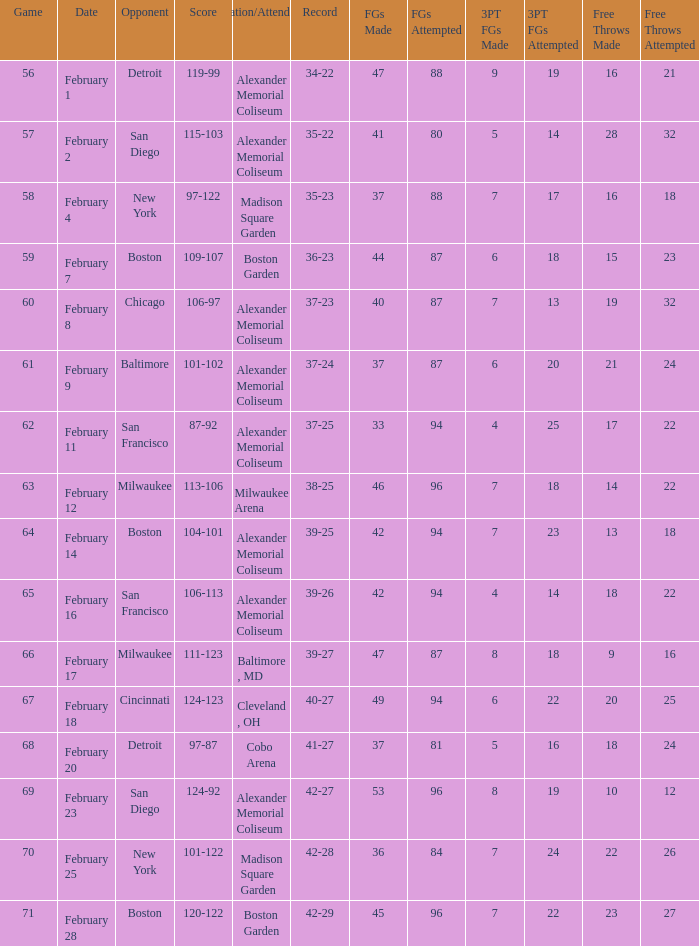What is the Game # that scored 87-92? 62.0. 